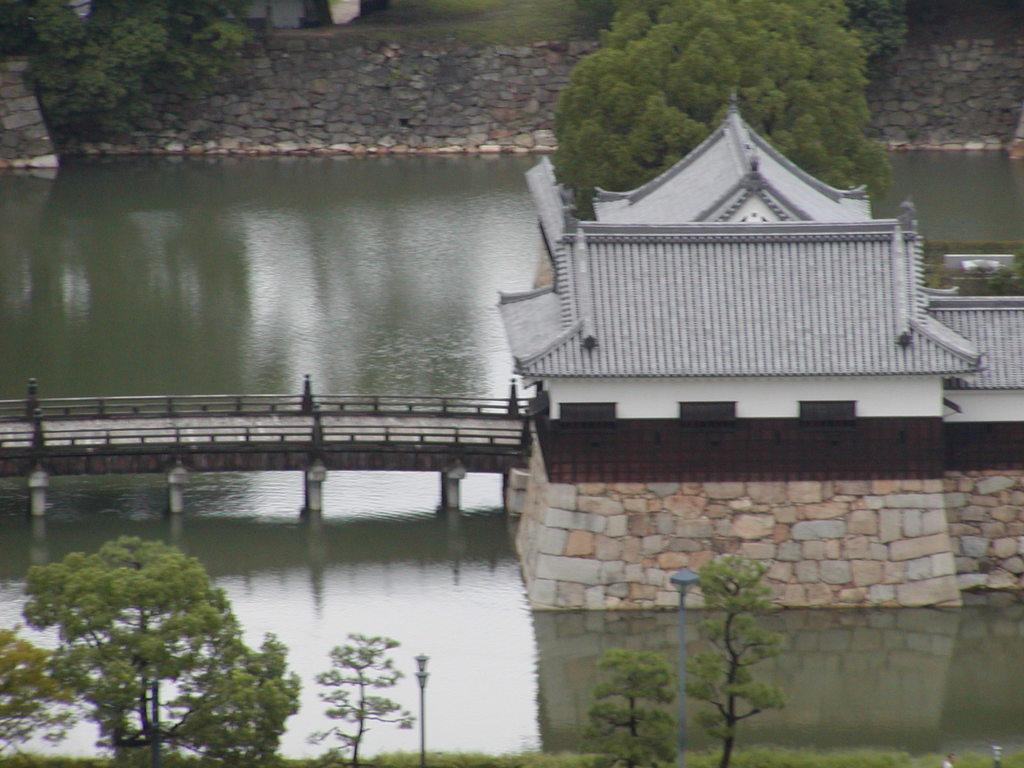What can be seen in the background of the image? There is a wall and trees in the background of the image. What is visible in the image besides the wall and trees? There is water visible in the image, as well as a bridge and a house. How many patches of earth can be seen in the image? There is no mention of patches of earth in the image; it features a wall, trees, water, a bridge, and a house. What type of pizzas are being served on the bridge in the image? There is no mention of pizzas in the image; it does not feature any food items. 